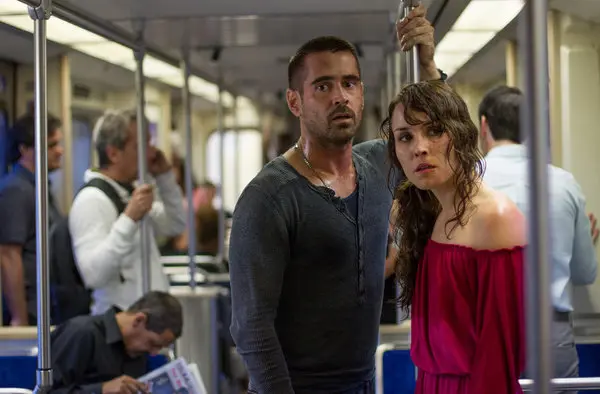What moment from the movie do you think this scene captures? This scene seems to capture a pivotal and tense moment in the movie "Dead Man Down." The expressions of Noomi Rapace and Colin Farrell suggest they are in a dire situation. The setting within a confined subway car adds an element of claustrophobia and urgency, possibly highlighting a key confrontation or revelation in the narrative. Can you describe the emotions portrayed by the characters in this scene? Both characters exhibit a mix of fear and determination. Noomi Rapace's character's wide eyes and slightly agape mouth suggest shock and concern, while Colin Farrell's furrowed brow and tense posture indicate preparedness for an imminent challenge. Their body language implies they are either bracing for or reacting to a significant threat or event. Imagine this subway scene takes place under completely different circumstances. Create a story where these characters appear relaxed and happy. In an alternate scenario, Noomi Rapace and Colin Farrell's characters could be enjoying a serene moment together on the subway. Noomi in a bright floral dress and Colin in a casual, light-colored shirt are seated side by side, smiling and laughing as they share jokes and reminisce about happier times. The subway car is filled with soft, natural light filtering through the windows, and other passengers are seen engaged in similarly cheerful conversations or quietly enjoying their journey. This alternate reality depicts a rare moment of peace and joy, a stark contrast to the intense atmosphere of their usual encounters. 